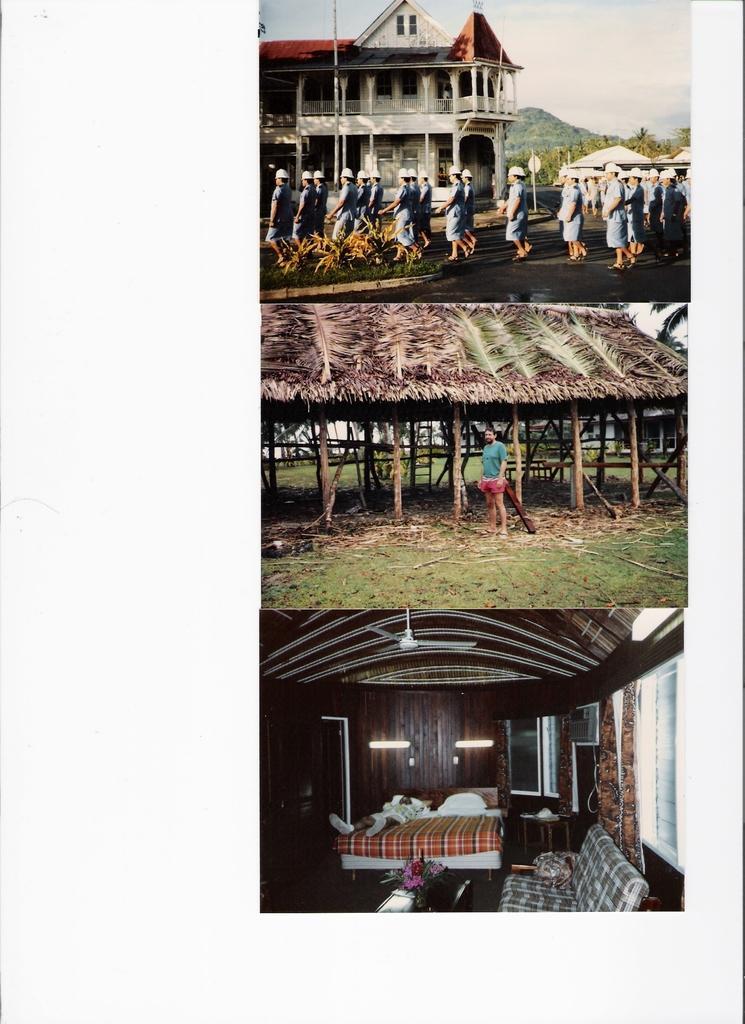Can you describe this image briefly? This is an edited image. On the right we can see the pictures containing sky, building, group of persons, tents, trees, shed, ceiling fan, bed, couch and some other objects. 